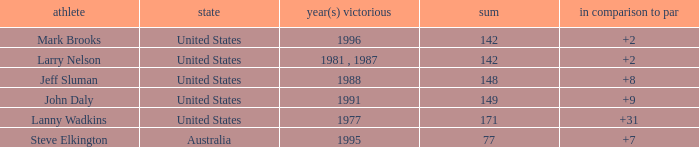Name the Total of jeff sluman? 148.0. 